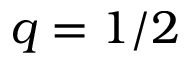Convert formula to latex. <formula><loc_0><loc_0><loc_500><loc_500>q = 1 / 2</formula> 